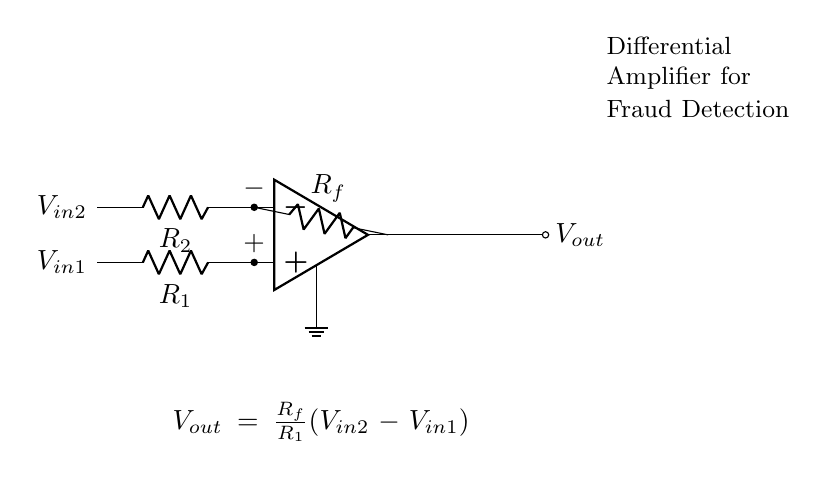What type of amplifier is shown in the circuit? The circuit depicts a differential amplifier, which is a type of amplifier that amplifies the difference between two input voltages. It is characterized by its two input terminals: one for the positive input and the other for the negative input.
Answer: differential amplifier What are the values of the resistors labeled in the circuit? The circuit diagram labels three resistors: R1, R2, and Rf. Their specific numerical values are not provided within the diagram, but these resistors determine the gain and functioning of the differential amplifier.
Answer: R1, R2, Rf What is the output voltage formula in the circuit? The output voltage formula provided in the circuit is expressed as Vout = (Rf/R1)(Vin2 - Vin1). This equation shows how the output voltage is proportional to the difference between the two input voltages, scaled by the ratio of Rf to R1.
Answer: Vout = (Rf/R1)(Vin2 - Vin1) Which node in the circuit is the non-inverting input? The non-inverting input is located at the top of the operational amplifier symbol in the circuit, indicated by the plus sign. This input receives the positive signal voltage.
Answer: non-inverting input How does the differential amplifier detect small voltage differences? A differential amplifier detects small voltage differences by amplifying the voltage difference between its two input terminals. When the input voltages Vin1 and Vin2 are close together, the circuit outputs a small voltage proportional to their difference, thanks to the feedback and input resistors.
Answer: by amplifying voltage differences What is the role of the feedback resistor Rf in the circuit? The feedback resistor Rf plays a crucial role in determining the gain of the differential amplifier. By setting the ratio of Rf to R1, it influences how much the output voltage responds to changes in the input voltage difference, thereby controlling amplification levels.
Answer: determine gain 